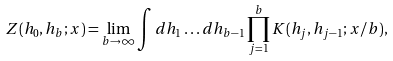Convert formula to latex. <formula><loc_0><loc_0><loc_500><loc_500>Z ( h _ { 0 } , h _ { b } ; x ) = \lim _ { b \to \infty } \int d h _ { 1 } \dots d h _ { b - 1 } \prod _ { j = 1 } ^ { b } K ( h _ { j } , h _ { j - 1 } ; x / b ) ,</formula> 